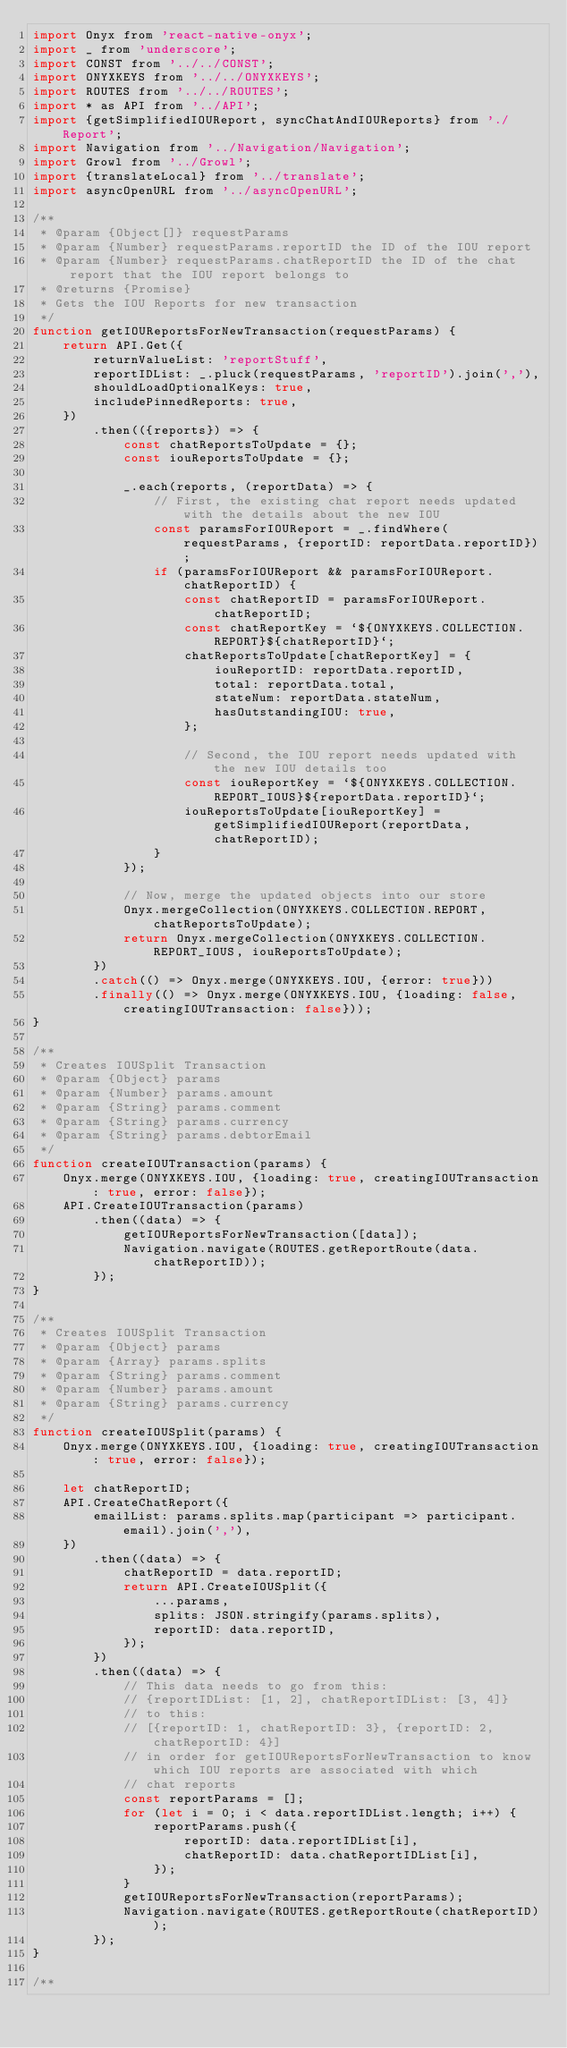Convert code to text. <code><loc_0><loc_0><loc_500><loc_500><_JavaScript_>import Onyx from 'react-native-onyx';
import _ from 'underscore';
import CONST from '../../CONST';
import ONYXKEYS from '../../ONYXKEYS';
import ROUTES from '../../ROUTES';
import * as API from '../API';
import {getSimplifiedIOUReport, syncChatAndIOUReports} from './Report';
import Navigation from '../Navigation/Navigation';
import Growl from '../Growl';
import {translateLocal} from '../translate';
import asyncOpenURL from '../asyncOpenURL';

/**
 * @param {Object[]} requestParams
 * @param {Number} requestParams.reportID the ID of the IOU report
 * @param {Number} requestParams.chatReportID the ID of the chat report that the IOU report belongs to
 * @returns {Promise}
 * Gets the IOU Reports for new transaction
 */
function getIOUReportsForNewTransaction(requestParams) {
    return API.Get({
        returnValueList: 'reportStuff',
        reportIDList: _.pluck(requestParams, 'reportID').join(','),
        shouldLoadOptionalKeys: true,
        includePinnedReports: true,
    })
        .then(({reports}) => {
            const chatReportsToUpdate = {};
            const iouReportsToUpdate = {};

            _.each(reports, (reportData) => {
                // First, the existing chat report needs updated with the details about the new IOU
                const paramsForIOUReport = _.findWhere(requestParams, {reportID: reportData.reportID});
                if (paramsForIOUReport && paramsForIOUReport.chatReportID) {
                    const chatReportID = paramsForIOUReport.chatReportID;
                    const chatReportKey = `${ONYXKEYS.COLLECTION.REPORT}${chatReportID}`;
                    chatReportsToUpdate[chatReportKey] = {
                        iouReportID: reportData.reportID,
                        total: reportData.total,
                        stateNum: reportData.stateNum,
                        hasOutstandingIOU: true,
                    };

                    // Second, the IOU report needs updated with the new IOU details too
                    const iouReportKey = `${ONYXKEYS.COLLECTION.REPORT_IOUS}${reportData.reportID}`;
                    iouReportsToUpdate[iouReportKey] = getSimplifiedIOUReport(reportData, chatReportID);
                }
            });

            // Now, merge the updated objects into our store
            Onyx.mergeCollection(ONYXKEYS.COLLECTION.REPORT, chatReportsToUpdate);
            return Onyx.mergeCollection(ONYXKEYS.COLLECTION.REPORT_IOUS, iouReportsToUpdate);
        })
        .catch(() => Onyx.merge(ONYXKEYS.IOU, {error: true}))
        .finally(() => Onyx.merge(ONYXKEYS.IOU, {loading: false, creatingIOUTransaction: false}));
}

/**
 * Creates IOUSplit Transaction
 * @param {Object} params
 * @param {Number} params.amount
 * @param {String} params.comment
 * @param {String} params.currency
 * @param {String} params.debtorEmail
 */
function createIOUTransaction(params) {
    Onyx.merge(ONYXKEYS.IOU, {loading: true, creatingIOUTransaction: true, error: false});
    API.CreateIOUTransaction(params)
        .then((data) => {
            getIOUReportsForNewTransaction([data]);
            Navigation.navigate(ROUTES.getReportRoute(data.chatReportID));
        });
}

/**
 * Creates IOUSplit Transaction
 * @param {Object} params
 * @param {Array} params.splits
 * @param {String} params.comment
 * @param {Number} params.amount
 * @param {String} params.currency
 */
function createIOUSplit(params) {
    Onyx.merge(ONYXKEYS.IOU, {loading: true, creatingIOUTransaction: true, error: false});

    let chatReportID;
    API.CreateChatReport({
        emailList: params.splits.map(participant => participant.email).join(','),
    })
        .then((data) => {
            chatReportID = data.reportID;
            return API.CreateIOUSplit({
                ...params,
                splits: JSON.stringify(params.splits),
                reportID: data.reportID,
            });
        })
        .then((data) => {
            // This data needs to go from this:
            // {reportIDList: [1, 2], chatReportIDList: [3, 4]}
            // to this:
            // [{reportID: 1, chatReportID: 3}, {reportID: 2, chatReportID: 4}]
            // in order for getIOUReportsForNewTransaction to know which IOU reports are associated with which
            // chat reports
            const reportParams = [];
            for (let i = 0; i < data.reportIDList.length; i++) {
                reportParams.push({
                    reportID: data.reportIDList[i],
                    chatReportID: data.chatReportIDList[i],
                });
            }
            getIOUReportsForNewTransaction(reportParams);
            Navigation.navigate(ROUTES.getReportRoute(chatReportID));
        });
}

/**</code> 